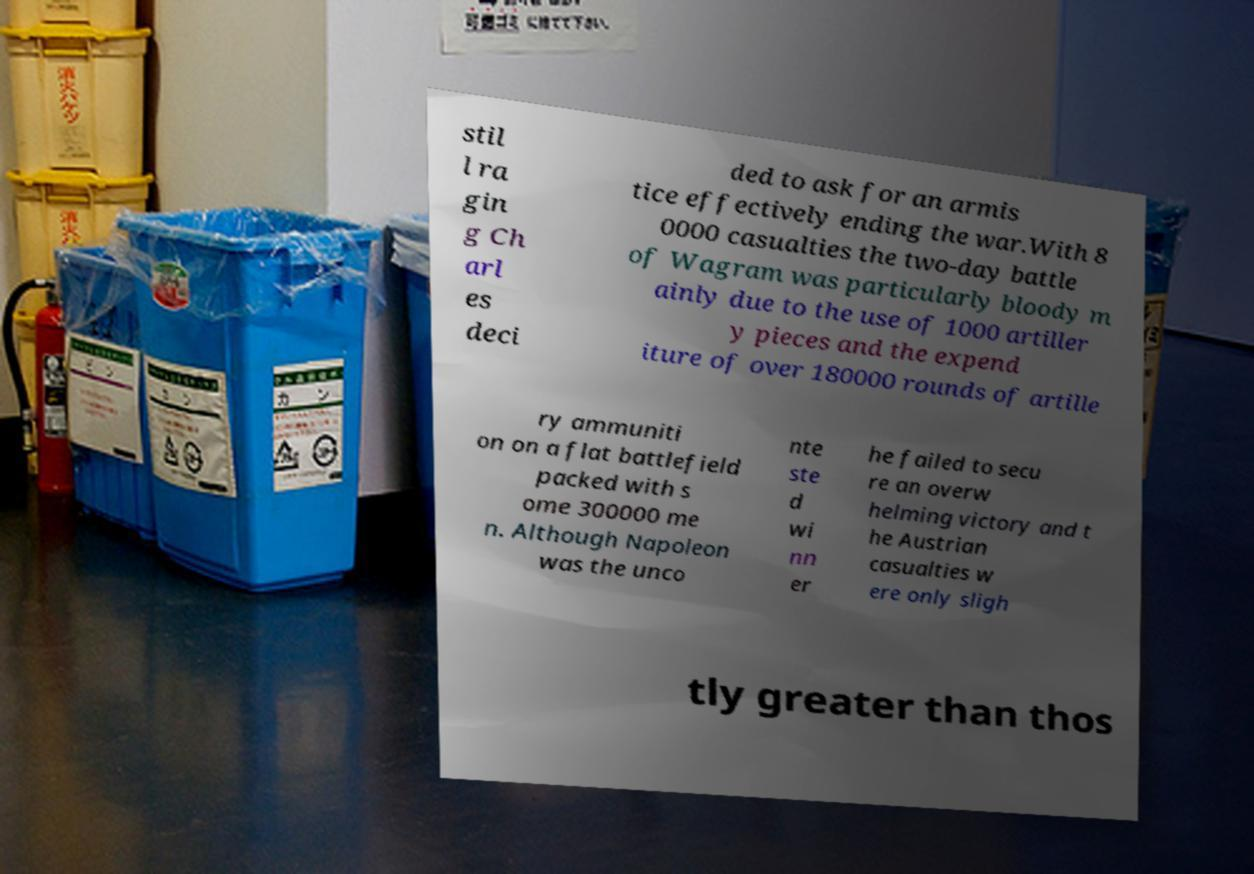Can you accurately transcribe the text from the provided image for me? stil l ra gin g Ch arl es deci ded to ask for an armis tice effectively ending the war.With 8 0000 casualties the two-day battle of Wagram was particularly bloody m ainly due to the use of 1000 artiller y pieces and the expend iture of over 180000 rounds of artille ry ammuniti on on a flat battlefield packed with s ome 300000 me n. Although Napoleon was the unco nte ste d wi nn er he failed to secu re an overw helming victory and t he Austrian casualties w ere only sligh tly greater than thos 